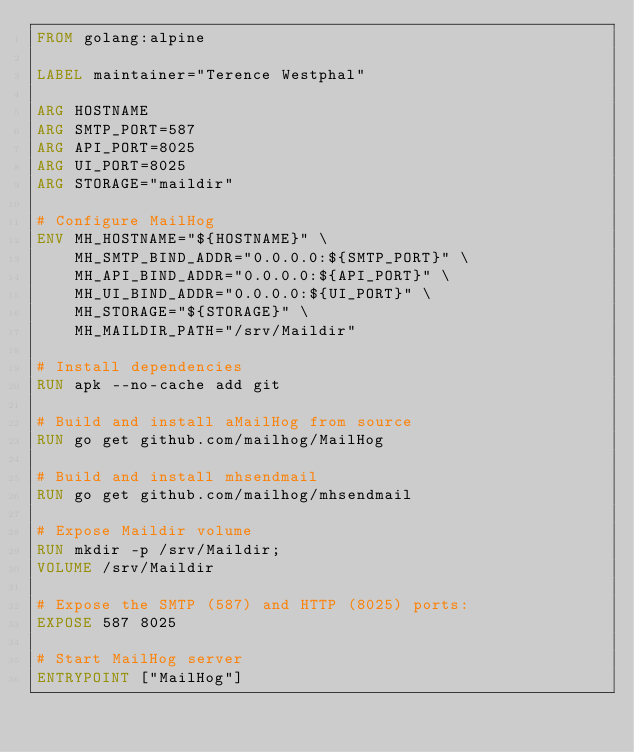Convert code to text. <code><loc_0><loc_0><loc_500><loc_500><_Dockerfile_>FROM golang:alpine

LABEL maintainer="Terence Westphal"

ARG HOSTNAME
ARG SMTP_PORT=587
ARG API_PORT=8025
ARG UI_PORT=8025
ARG STORAGE="maildir"

# Configure MailHog
ENV MH_HOSTNAME="${HOSTNAME}" \
    MH_SMTP_BIND_ADDR="0.0.0.0:${SMTP_PORT}" \
    MH_API_BIND_ADDR="0.0.0.0:${API_PORT}" \
    MH_UI_BIND_ADDR="0.0.0.0:${UI_PORT}" \
    MH_STORAGE="${STORAGE}" \
    MH_MAILDIR_PATH="/srv/Maildir"

# Install dependencies
RUN apk --no-cache add git

# Build and install aMailHog from source
RUN go get github.com/mailhog/MailHog

# Build and install mhsendmail
RUN go get github.com/mailhog/mhsendmail

# Expose Maildir volume
RUN mkdir -p /srv/Maildir;
VOLUME /srv/Maildir

# Expose the SMTP (587) and HTTP (8025) ports:
EXPOSE 587 8025

# Start MailHog server
ENTRYPOINT ["MailHog"]</code> 